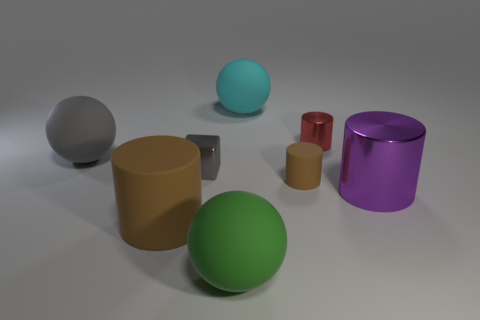Are there any patterns or motifs visible on any of the objects? No, the objects displayed in the image all have a uniform color with no discernible patterns or motifs on their surfaces. 